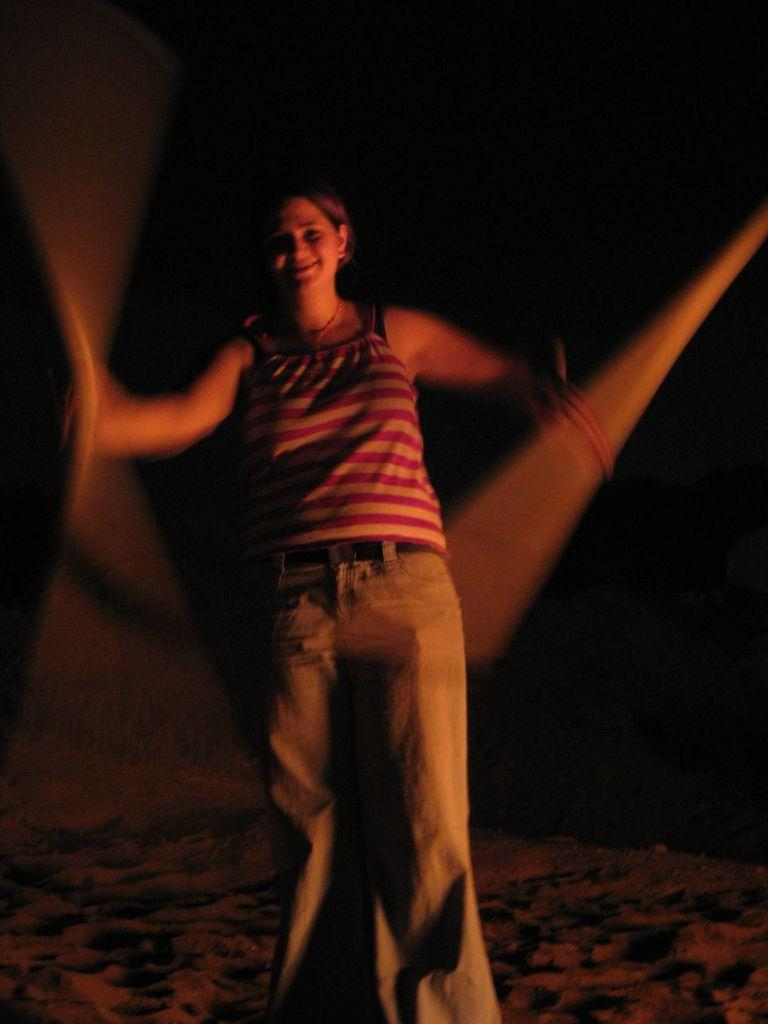Who is the main subject in the image? There is a woman in the center of the image. What is the woman doing in the image? The woman is standing, but the specific activity she is engaged in is not mentioned in the facts. What type of surface is at the bottom of the image? There is sand at the bottom of the image. What type of jam is being spread on the cream in the image? There is no jam or cream present in the image; it features a woman standing on sand. 